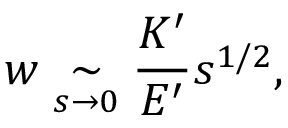<formula> <loc_0><loc_0><loc_500><loc_500>w \underset { s \rightarrow 0 } { \sim } \frac { K ^ { \prime } } { E ^ { \prime } } s ^ { 1 / 2 } ,</formula> 